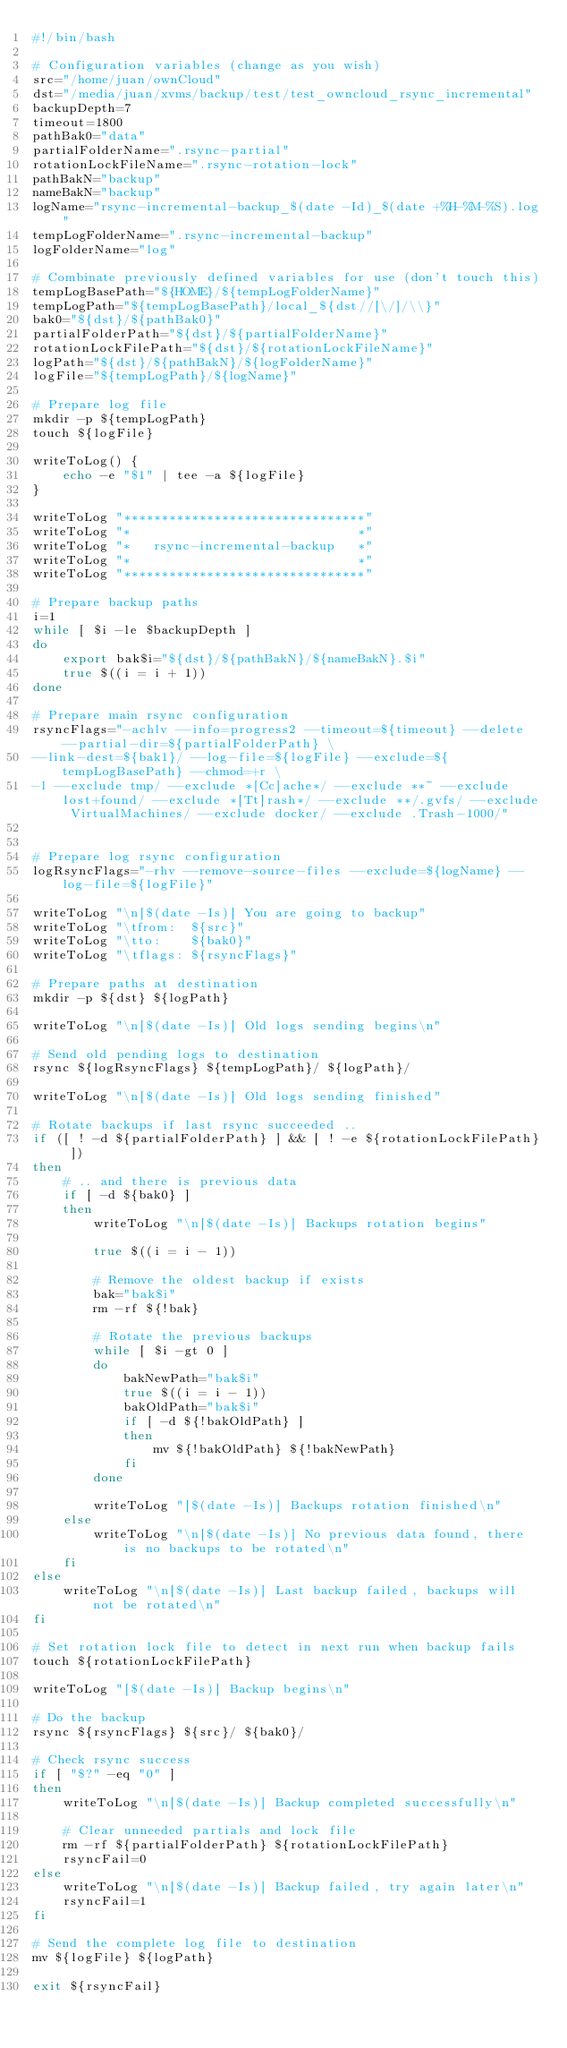<code> <loc_0><loc_0><loc_500><loc_500><_Bash_>#!/bin/bash

# Configuration variables (change as you wish)
src="/home/juan/ownCloud"
dst="/media/juan/xvms/backup/test/test_owncloud_rsync_incremental"
backupDepth=7
timeout=1800
pathBak0="data"
partialFolderName=".rsync-partial"
rotationLockFileName=".rsync-rotation-lock"
pathBakN="backup"
nameBakN="backup"
logName="rsync-incremental-backup_$(date -Id)_$(date +%H-%M-%S).log"
tempLogFolderName=".rsync-incremental-backup"
logFolderName="log"

# Combinate previously defined variables for use (don't touch this)
tempLogBasePath="${HOME}/${tempLogFolderName}"
tempLogPath="${tempLogBasePath}/local_${dst//[\/]/\\}"
bak0="${dst}/${pathBak0}"
partialFolderPath="${dst}/${partialFolderName}"
rotationLockFilePath="${dst}/${rotationLockFileName}"
logPath="${dst}/${pathBakN}/${logFolderName}"
logFile="${tempLogPath}/${logName}"

# Prepare log file
mkdir -p ${tempLogPath}
touch ${logFile}

writeToLog() {
	echo -e "$1" | tee -a ${logFile}
}

writeToLog "********************************"
writeToLog "*                              *"
writeToLog "*   rsync-incremental-backup   *"
writeToLog "*                              *"
writeToLog "********************************"

# Prepare backup paths
i=1
while [ $i -le $backupDepth ]
do
	export bak$i="${dst}/${pathBakN}/${nameBakN}.$i"
	true $((i = i + 1))
done

# Prepare main rsync configuration
rsyncFlags="-achlv --info=progress2 --timeout=${timeout} --delete --partial-dir=${partialFolderPath} \
--link-dest=${bak1}/ --log-file=${logFile} --exclude=${tempLogBasePath} --chmod=+r \
-l --exclude tmp/ --exclude *[Cc]ache*/ --exclude **~ --exclude lost+found/ --exclude *[Tt]rash*/ --exclude **/.gvfs/ --exclude VirtualMachines/ --exclude docker/ --exclude .Trash-1000/"


# Prepare log rsync configuration
logRsyncFlags="-rhv --remove-source-files --exclude=${logName} --log-file=${logFile}"

writeToLog "\n[$(date -Is)] You are going to backup"
writeToLog "\tfrom:  ${src}"
writeToLog "\tto:    ${bak0}"
writeToLog "\tflags: ${rsyncFlags}"

# Prepare paths at destination
mkdir -p ${dst} ${logPath}

writeToLog "\n[$(date -Is)] Old logs sending begins\n"

# Send old pending logs to destination
rsync ${logRsyncFlags} ${tempLogPath}/ ${logPath}/

writeToLog "\n[$(date -Is)] Old logs sending finished"

# Rotate backups if last rsync succeeded ..
if ([ ! -d ${partialFolderPath} ] && [ ! -e ${rotationLockFilePath} ])
then
	# .. and there is previous data
	if [ -d ${bak0} ]
	then
		writeToLog "\n[$(date -Is)] Backups rotation begins"

		true $((i = i - 1))

		# Remove the oldest backup if exists
		bak="bak$i"
		rm -rf ${!bak}

		# Rotate the previous backups
		while [ $i -gt 0 ]
		do
			bakNewPath="bak$i"
			true $((i = i - 1))
			bakOldPath="bak$i"
			if [ -d ${!bakOldPath} ]
			then
				mv ${!bakOldPath} ${!bakNewPath}
			fi
		done

		writeToLog "[$(date -Is)] Backups rotation finished\n"
	else
		writeToLog "\n[$(date -Is)] No previous data found, there is no backups to be rotated\n"
	fi
else
	writeToLog "\n[$(date -Is)] Last backup failed, backups will not be rotated\n"
fi

# Set rotation lock file to detect in next run when backup fails
touch ${rotationLockFilePath}

writeToLog "[$(date -Is)] Backup begins\n"

# Do the backup
rsync ${rsyncFlags} ${src}/ ${bak0}/

# Check rsync success
if [ "$?" -eq "0" ]
then
	writeToLog "\n[$(date -Is)] Backup completed successfully\n"

	# Clear unneeded partials and lock file
	rm -rf ${partialFolderPath} ${rotationLockFilePath}
	rsyncFail=0
else
	writeToLog "\n[$(date -Is)] Backup failed, try again later\n"
	rsyncFail=1
fi

# Send the complete log file to destination
mv ${logFile} ${logPath}

exit ${rsyncFail}
</code> 